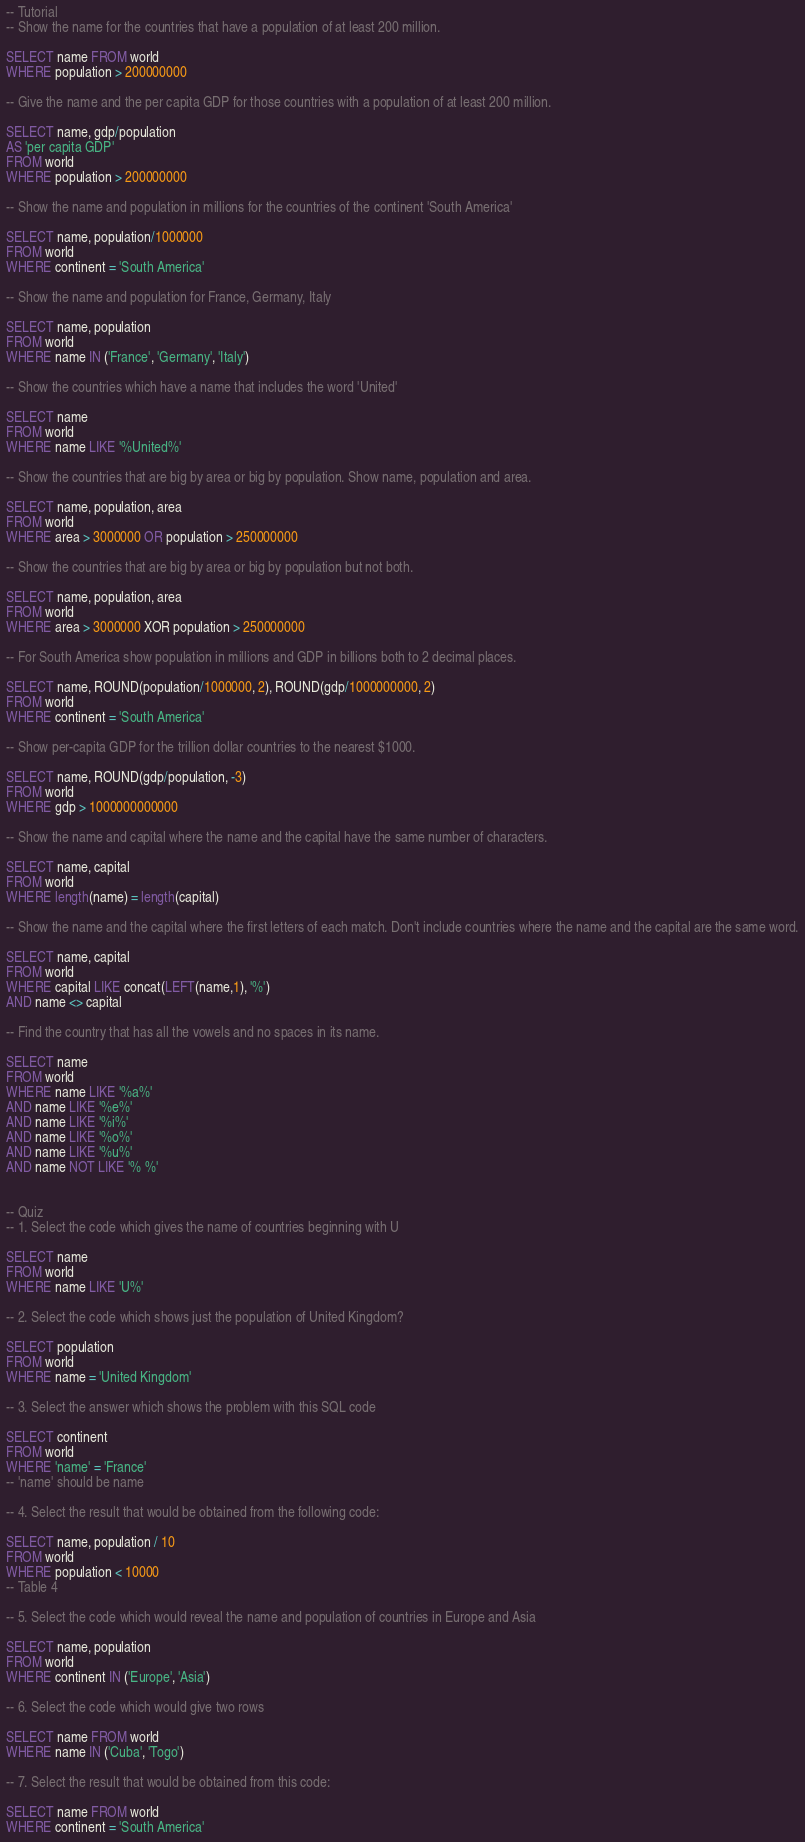Convert code to text. <code><loc_0><loc_0><loc_500><loc_500><_SQL_>-- Tutorial
-- Show the name for the countries that have a population of at least 200 million.

SELECT name FROM world
WHERE population > 200000000

-- Give the name and the per capita GDP for those countries with a population of at least 200 million.

SELECT name, gdp/population
AS 'per capita GDP'
FROM world
WHERE population > 200000000

-- Show the name and population in millions for the countries of the continent 'South America'

SELECT name, population/1000000
FROM world
WHERE continent = 'South America'

-- Show the name and population for France, Germany, Italy

SELECT name, population
FROM world
WHERE name IN ('France', 'Germany', 'Italy')

-- Show the countries which have a name that includes the word 'United'

SELECT name
FROM world
WHERE name LIKE '%United%'

-- Show the countries that are big by area or big by population. Show name, population and area.

SELECT name, population, area
FROM world
WHERE area > 3000000 OR population > 250000000

-- Show the countries that are big by area or big by population but not both.

SELECT name, population, area
FROM world
WHERE area > 3000000 XOR population > 250000000

-- For South America show population in millions and GDP in billions both to 2 decimal places.

SELECT name, ROUND(population/1000000, 2), ROUND(gdp/1000000000, 2)
FROM world
WHERE continent = 'South America'

-- Show per-capita GDP for the trillion dollar countries to the nearest $1000.

SELECT name, ROUND(gdp/population, -3)
FROM world
WHERE gdp > 1000000000000

-- Show the name and capital where the name and the capital have the same number of characters.

SELECT name, capital
FROM world
WHERE length(name) = length(capital)

-- Show the name and the capital where the first letters of each match. Don't include countries where the name and the capital are the same word.

SELECT name, capital
FROM world
WHERE capital LIKE concat(LEFT(name,1), '%')
AND name <> capital

-- Find the country that has all the vowels and no spaces in its name.

SELECT name
FROM world
WHERE name LIKE '%a%'
AND name LIKE '%e%'
AND name LIKE '%i%'
AND name LIKE '%o%'
AND name LIKE '%u%'
AND name NOT LIKE '% %'


-- Quiz
-- 1. Select the code which gives the name of countries beginning with U

SELECT name
FROM world
WHERE name LIKE 'U%'

-- 2. Select the code which shows just the population of United Kingdom?

SELECT population
FROM world
WHERE name = 'United Kingdom'

-- 3. Select the answer which shows the problem with this SQL code 

SELECT continent 
FROM world 
WHERE 'name' = 'France'
-- 'name' should be name

-- 4. Select the result that would be obtained from the following code:

SELECT name, population / 10 
FROM world 
WHERE population < 10000
-- Table 4

-- 5. Select the code which would reveal the name and population of countries in Europe and Asia

SELECT name, population
FROM world
WHERE continent IN ('Europe', 'Asia')

-- 6. Select the code which would give two rows

SELECT name FROM world
WHERE name IN ('Cuba', 'Togo')

-- 7. Select the result that would be obtained from this code:

SELECT name FROM world
WHERE continent = 'South America'</code> 